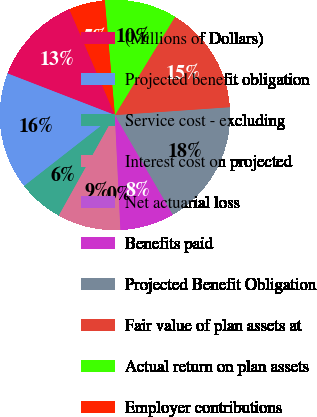Convert chart. <chart><loc_0><loc_0><loc_500><loc_500><pie_chart><fcel>(Millions of Dollars)<fcel>Projected benefit obligation<fcel>Service cost - excluding<fcel>Interest cost on projected<fcel>Net actuarial loss<fcel>Benefits paid<fcel>Projected Benefit Obligation<fcel>Fair value of plan assets at<fcel>Actual return on plan assets<fcel>Employer contributions<nl><fcel>12.65%<fcel>16.44%<fcel>6.34%<fcel>8.86%<fcel>0.02%<fcel>7.6%<fcel>17.71%<fcel>15.18%<fcel>10.13%<fcel>5.07%<nl></chart> 